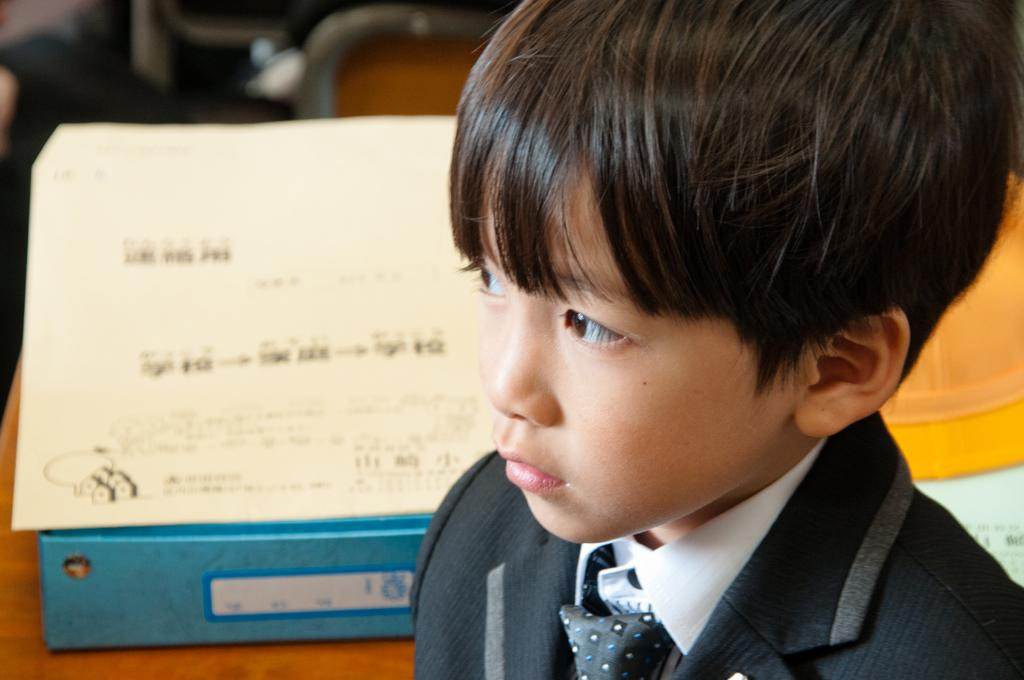Who is the main subject in the foreground of the image? There is a boy in the foreground of the image. What can be seen in the background of the image? There is a paper in the background of the image. What color is the object on the table in the background? There is a blue color object on a table in the background of the image. What type of plant is growing on the boy's head in the image? There is no plant growing on the boy's head in the image. What kind of rock can be seen in the boy's hand in the image? There is no rock visible in the boy's hand in the image. 